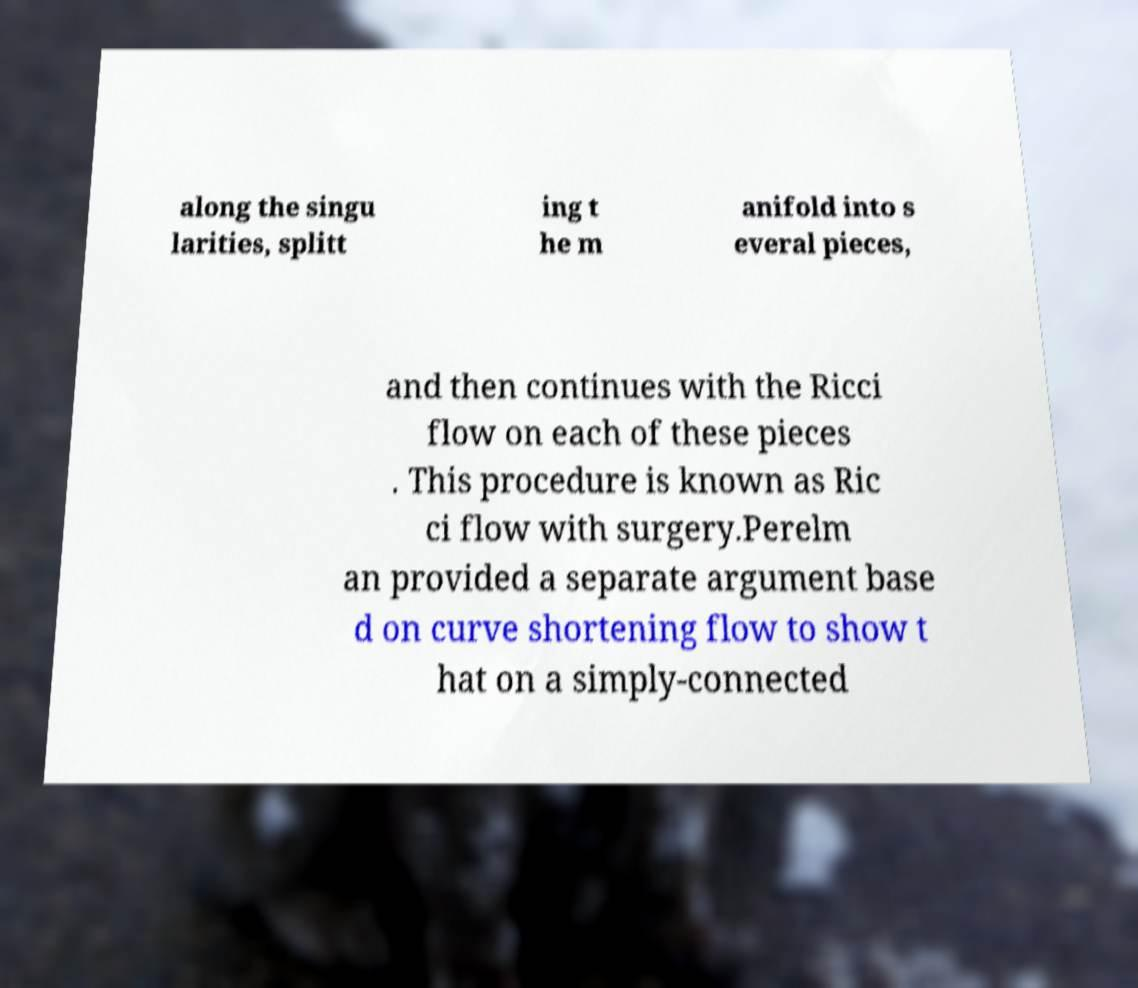Could you extract and type out the text from this image? along the singu larities, splitt ing t he m anifold into s everal pieces, and then continues with the Ricci flow on each of these pieces . This procedure is known as Ric ci flow with surgery.Perelm an provided a separate argument base d on curve shortening flow to show t hat on a simply-connected 